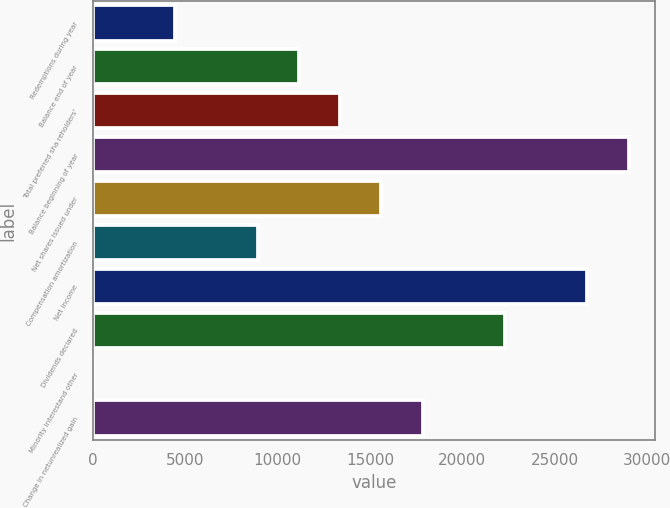Convert chart. <chart><loc_0><loc_0><loc_500><loc_500><bar_chart><fcel>Redemptions during year<fcel>Balance end of year<fcel>Total preferred sha reholders'<fcel>Balance beginning of year<fcel>Net shares issued under<fcel>Compensation amortization<fcel>Net income<fcel>Dividends declared<fcel>Minority interestand other<fcel>Change in netunrealized gain<nl><fcel>4470.2<fcel>11157.5<fcel>13386.6<fcel>28990.3<fcel>15615.7<fcel>8928.4<fcel>26761.2<fcel>22303<fcel>12<fcel>17844.8<nl></chart> 